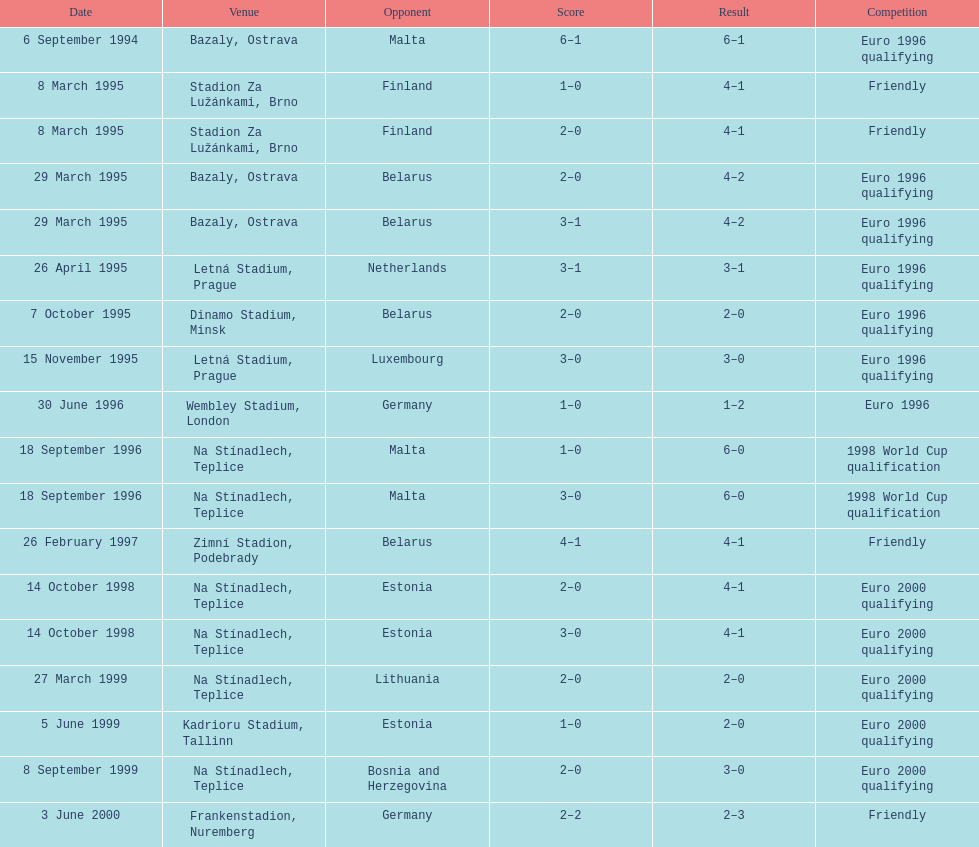How many games took place in ostrava? 2. 